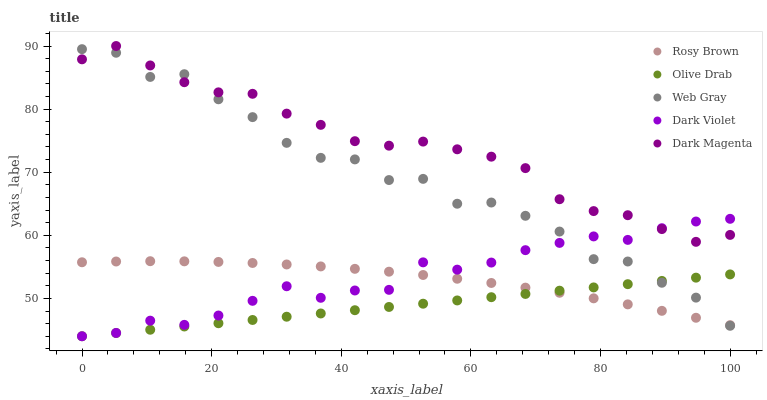Does Olive Drab have the minimum area under the curve?
Answer yes or no. Yes. Does Dark Magenta have the maximum area under the curve?
Answer yes or no. Yes. Does Web Gray have the minimum area under the curve?
Answer yes or no. No. Does Web Gray have the maximum area under the curve?
Answer yes or no. No. Is Olive Drab the smoothest?
Answer yes or no. Yes. Is Web Gray the roughest?
Answer yes or no. Yes. Is Dark Violet the smoothest?
Answer yes or no. No. Is Dark Violet the roughest?
Answer yes or no. No. Does Dark Violet have the lowest value?
Answer yes or no. Yes. Does Web Gray have the lowest value?
Answer yes or no. No. Does Dark Magenta have the highest value?
Answer yes or no. Yes. Does Web Gray have the highest value?
Answer yes or no. No. Is Rosy Brown less than Dark Magenta?
Answer yes or no. Yes. Is Dark Magenta greater than Olive Drab?
Answer yes or no. Yes. Does Web Gray intersect Olive Drab?
Answer yes or no. Yes. Is Web Gray less than Olive Drab?
Answer yes or no. No. Is Web Gray greater than Olive Drab?
Answer yes or no. No. Does Rosy Brown intersect Dark Magenta?
Answer yes or no. No. 